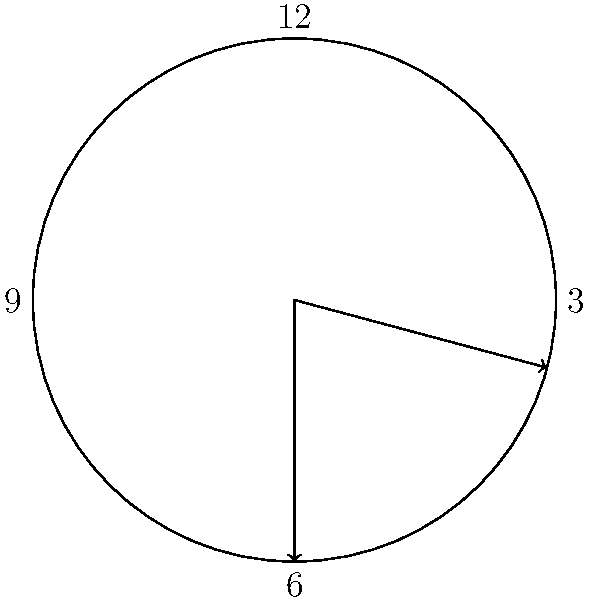In "A Tale of Two Cities" by Charles Dickens, the story begins with the famous line "It was the best of times, it was the worst of times." If we imagine this moment captured on a clock face at exactly 3:30, what is the angle between the hour and minute hands? To solve this problem, let's follow these steps:

1. Calculate the angle of the hour hand from 12 o'clock:
   - Each hour represents 30° (360° ÷ 12 = 30°)
   - 3 hours = 3 × 30° = 90°
   - The minute hand has moved halfway, so we add half of 30°: 90° + 15° = 105°

2. Calculate the angle of the minute hand from 12 o'clock:
   - Each minute represents 6° (360° ÷ 60 = 6°)
   - 30 minutes = 30 × 6° = 180°

3. Find the difference between these angles:
   $180° - 105° = 75°$

Therefore, the angle between the hour and minute hands at 3:30 is 75°.

This straightforward calculation mirrors the clear and direct narrative style often found in classic literature, such as Dickens' works.
Answer: 75° 